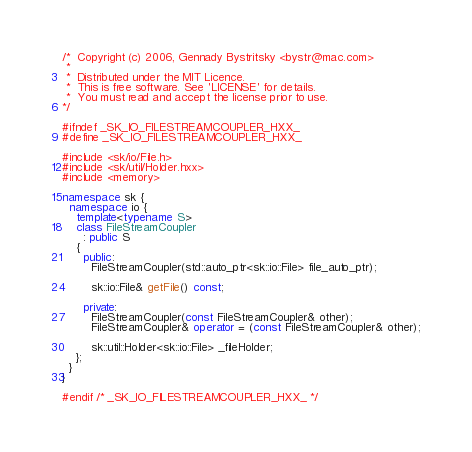<code> <loc_0><loc_0><loc_500><loc_500><_C++_>/*  Copyright (c) 2006, Gennady Bystritsky <bystr@mac.com>
 *
 *  Distributed under the MIT Licence.
 *  This is free software. See 'LICENSE' for details.
 *  You must read and accept the license prior to use.
*/

#ifndef _SK_IO_FILESTREAMCOUPLER_HXX_
#define _SK_IO_FILESTREAMCOUPLER_HXX_

#include <sk/io/File.h>
#include <sk/util/Holder.hxx>
#include <memory>

namespace sk {
  namespace io {
    template<typename S>
    class FileStreamCoupler
      : public S
    {
      public:
        FileStreamCoupler(std::auto_ptr<sk::io::File> file_auto_ptr);

        sk::io::File& getFile() const;

      private:
        FileStreamCoupler(const FileStreamCoupler& other);
        FileStreamCoupler& operator = (const FileStreamCoupler& other);

        sk::util::Holder<sk::io::File> _fileHolder;
    };
  }
}

#endif /* _SK_IO_FILESTREAMCOUPLER_HXX_ */
</code> 